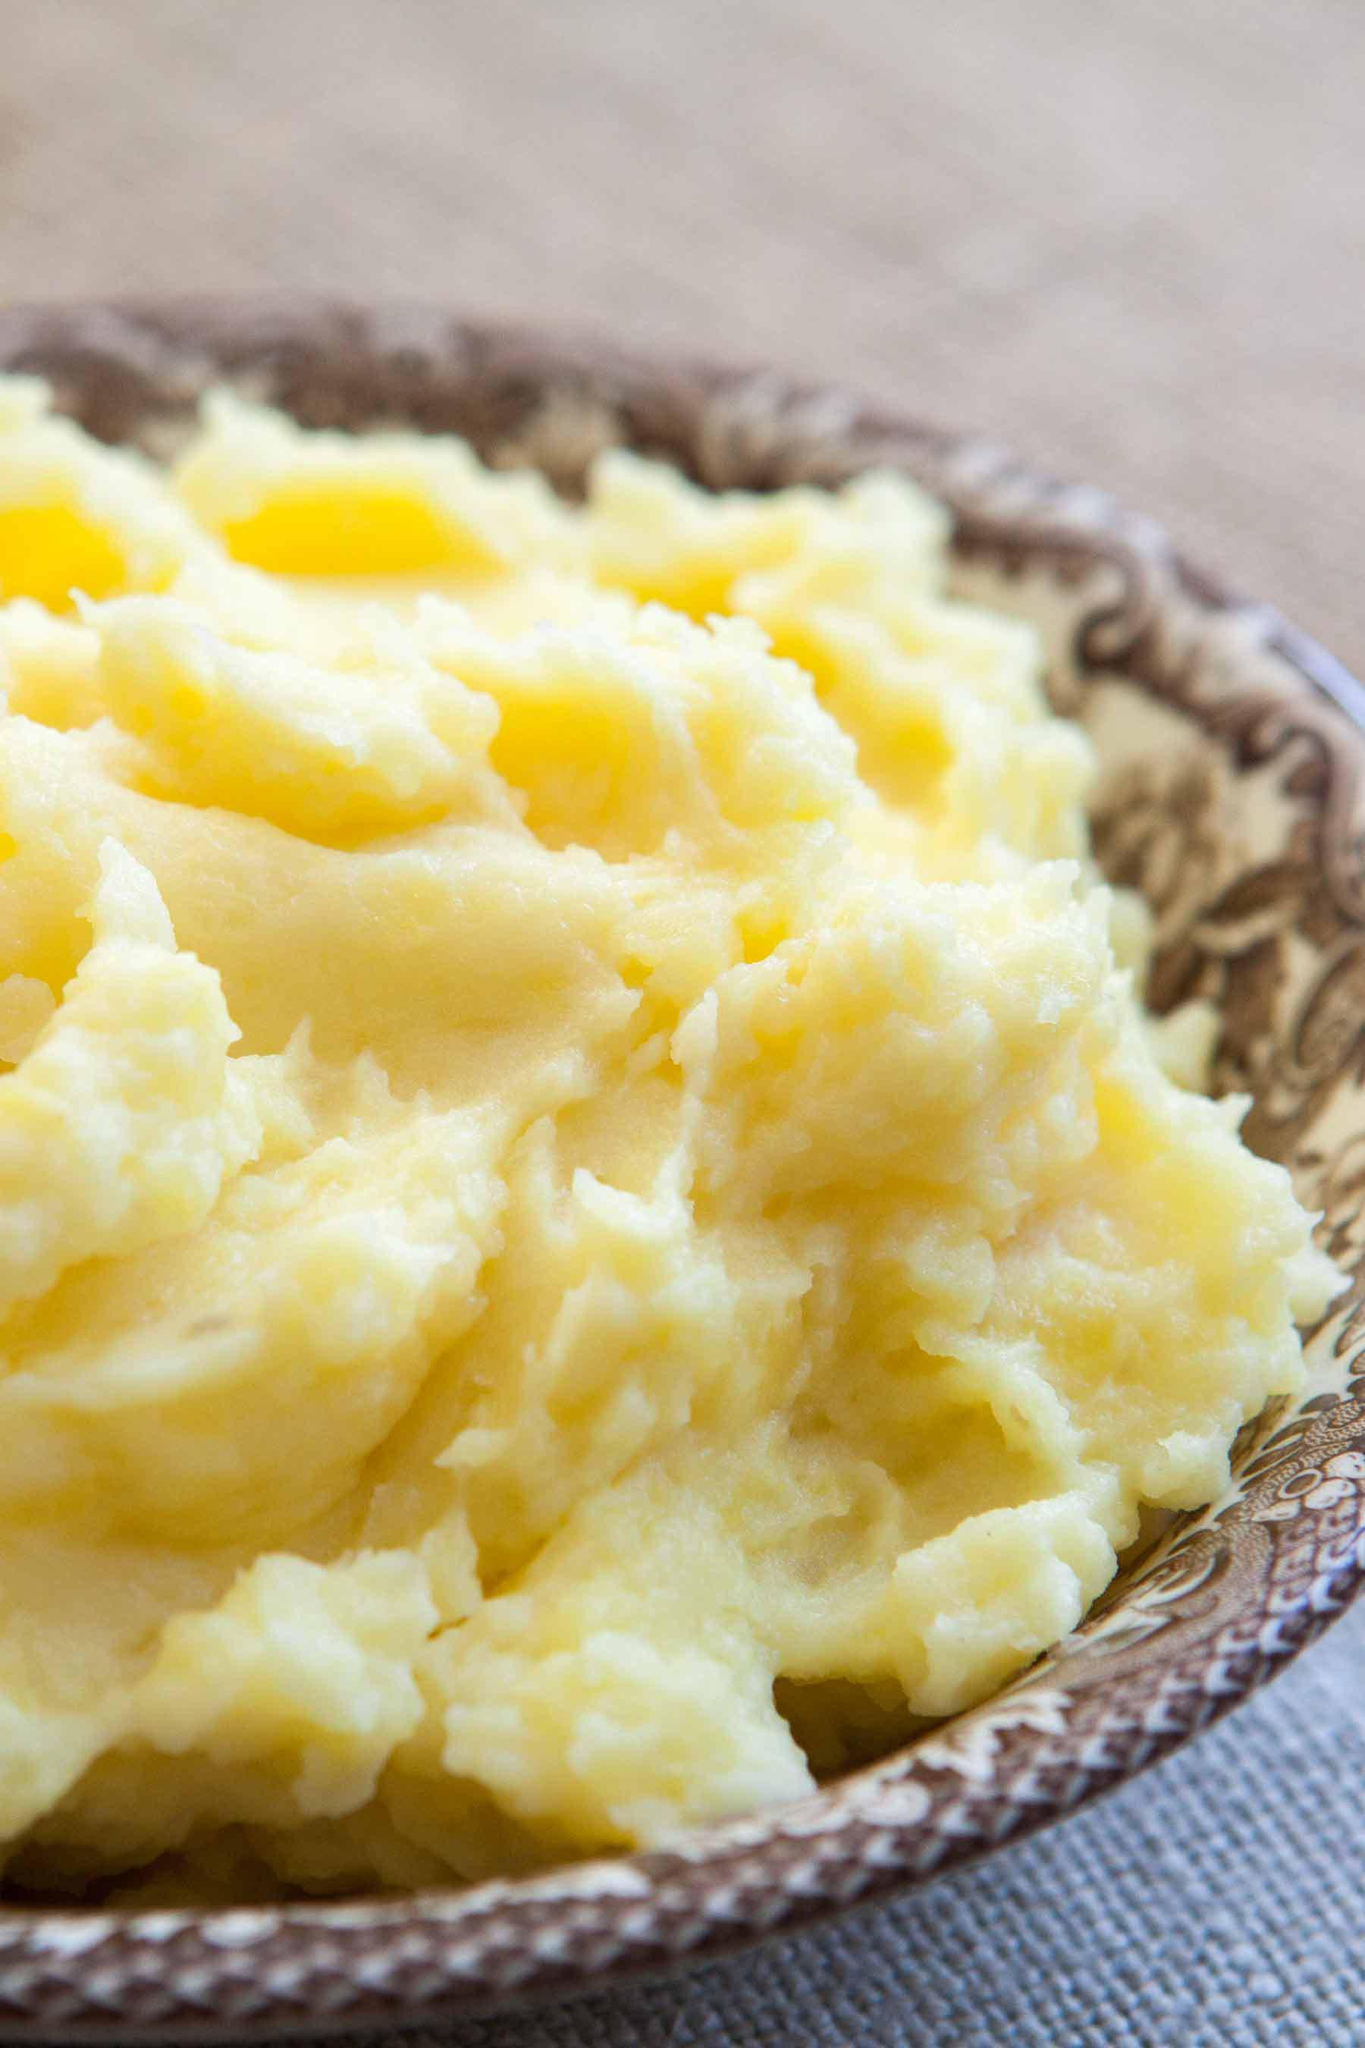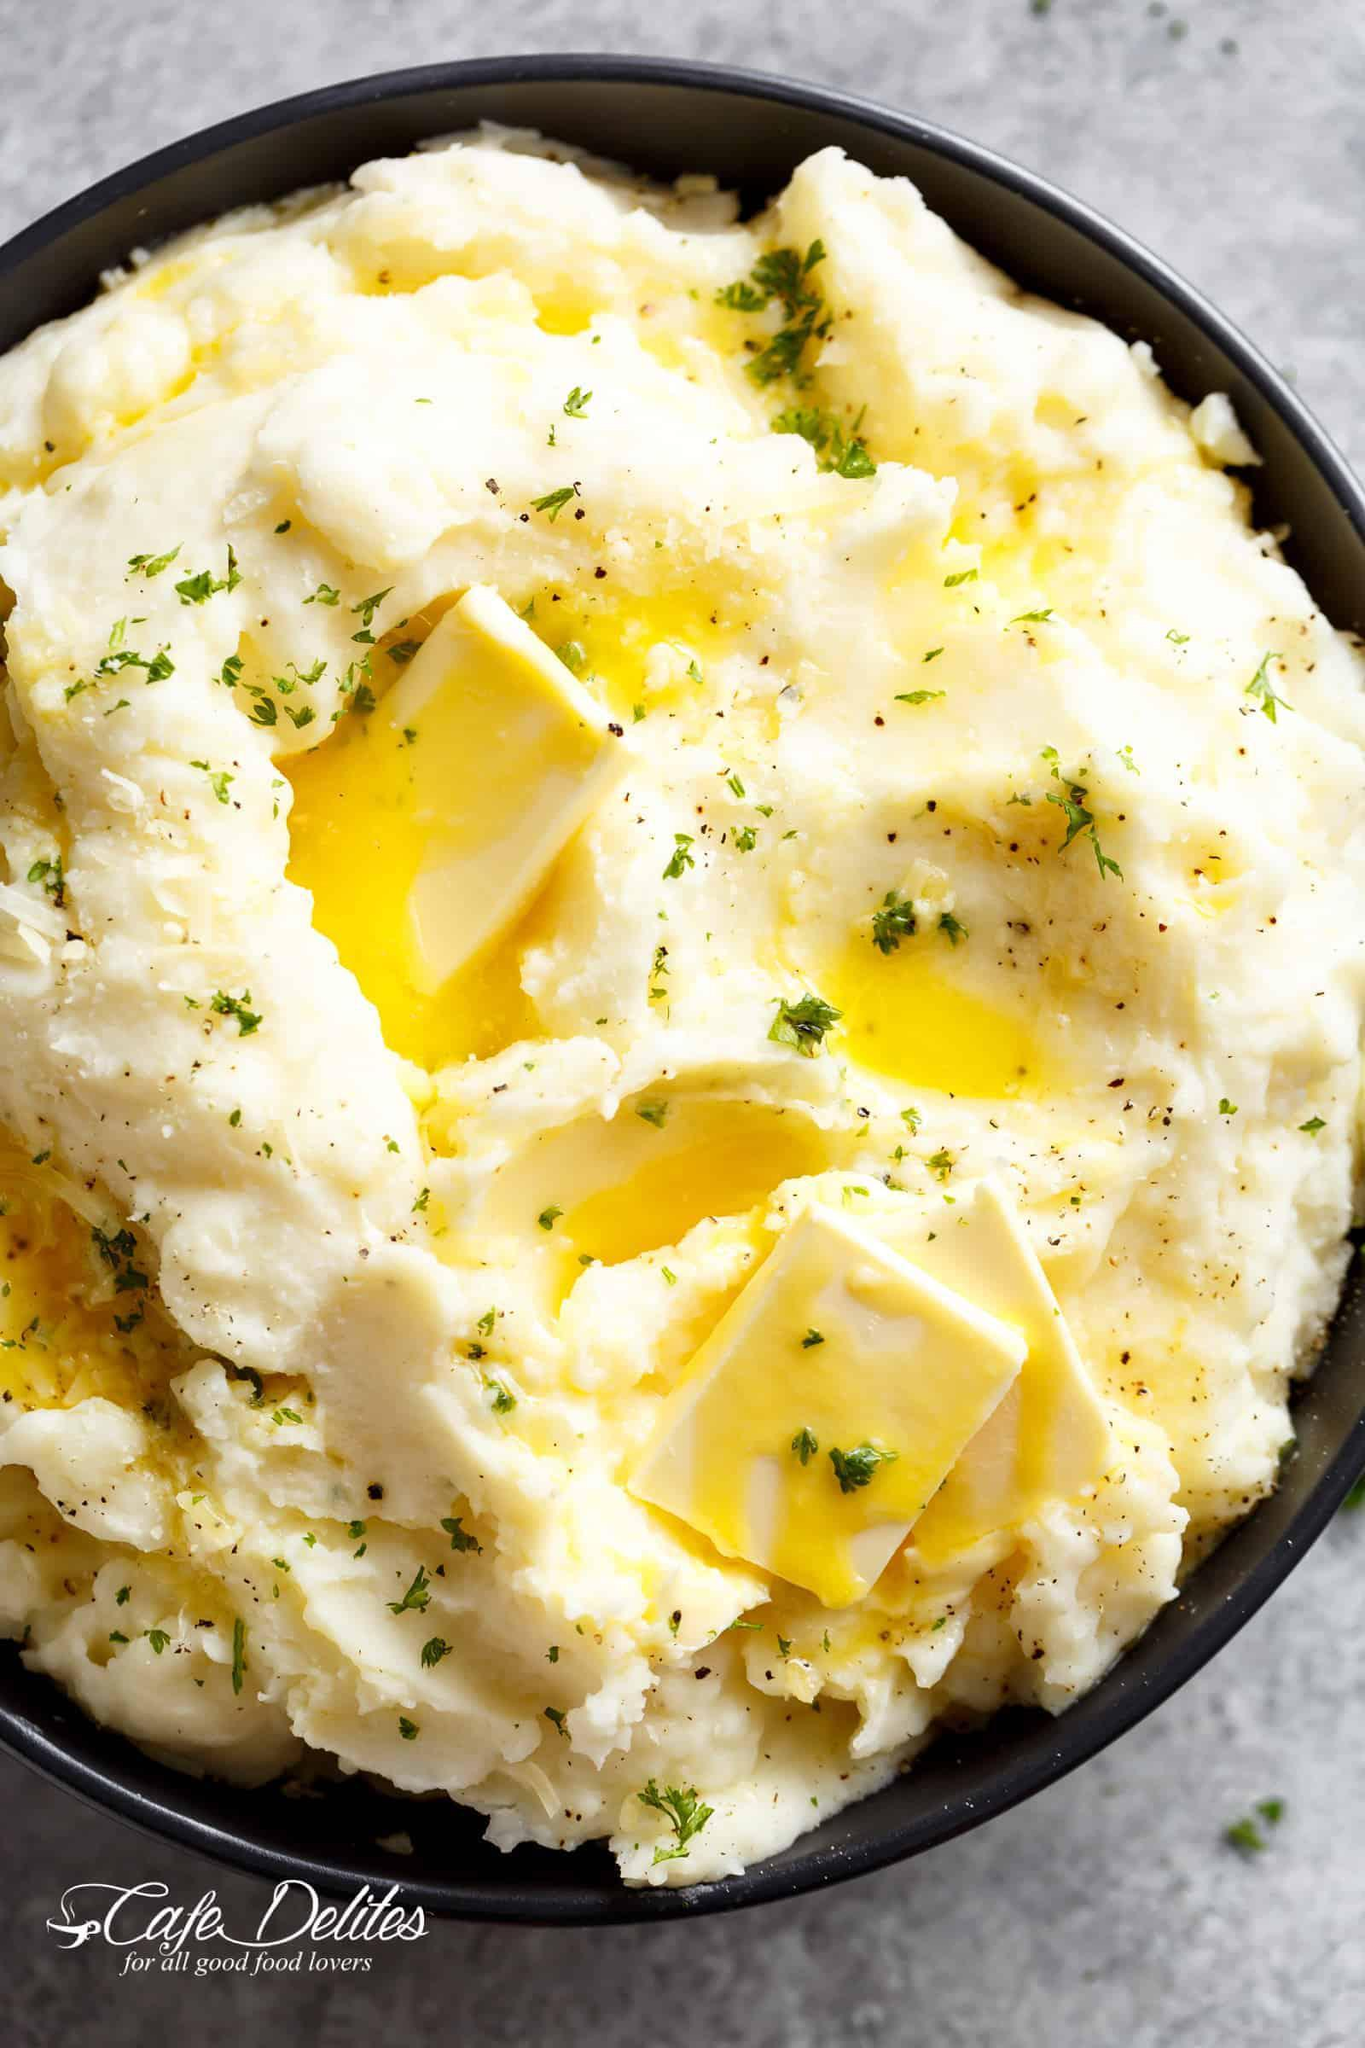The first image is the image on the left, the second image is the image on the right. Examine the images to the left and right. Is the description "The left and right image contains the same number of bowls of mash potatoes with at least one wooden bowl." accurate? Answer yes or no. No. The first image is the image on the left, the second image is the image on the right. Considering the images on both sides, is "A spoon is near a round brown bowl of garnished mashed potatoes in the left image." valid? Answer yes or no. No. 